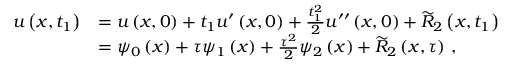Convert formula to latex. <formula><loc_0><loc_0><loc_500><loc_500>\begin{array} { r l } { { u } \left ( x , { t } _ { 1 } \right ) } & { = { u } \left ( x , 0 \right ) + { { t } _ { 1 } } { u } ^ { \prime } \left ( x , 0 \right ) + \frac { { t } _ { 1 } ^ { 2 } } { 2 } { u } ^ { { \prime } { \prime } } \left ( x , 0 \right ) + { \widetilde { R } } _ { 2 } \left ( x , { t } _ { 1 } \right ) } \\ & { = { \psi } _ { 0 } \left ( x \right ) + { \tau } { \psi } _ { 1 } \left ( x \right ) + \frac { { \tau } ^ { 2 } } { 2 } { \psi } _ { 2 } \left ( x \right ) + { \widetilde { R } } _ { 2 } \left ( x , { \tau } \right ) \, , } \end{array}</formula> 